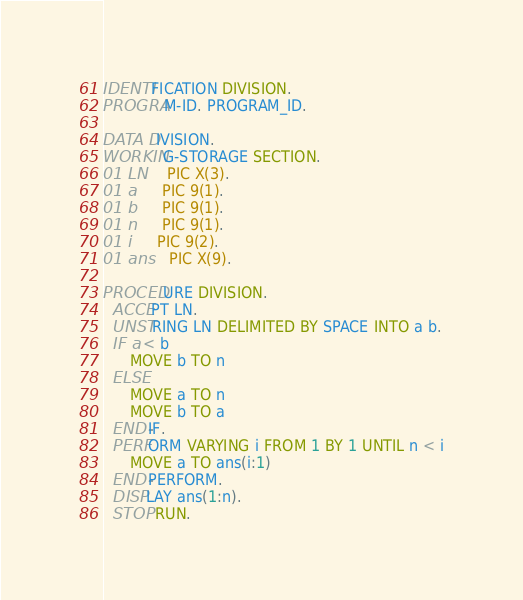Convert code to text. <code><loc_0><loc_0><loc_500><loc_500><_COBOL_>IDENTIFICATION DIVISION.
PROGRAM-ID. PROGRAM_ID.

DATA DIVISION.
WORKING-STORAGE SECTION.
01 LN     PIC X(3).
01 a      PIC 9(1).
01 b      PIC 9(1).
01 n      PIC 9(1).
01 i      PIC 9(2).
01 ans    PIC X(9).

PROCEDURE DIVISION.
  ACCEPT LN.
  UNSTRING LN DELIMITED BY SPACE INTO a b.
  IF a < b
      MOVE b TO n
  ELSE
      MOVE a TO n
      MOVE b TO a
  END-IF.
  PERFORM VARYING i FROM 1 BY 1 UNTIL n < i
      MOVE a TO ans(i:1)
  END-PERFORM.
  DISPLAY ans(1:n).
  STOP RUN.
</code> 